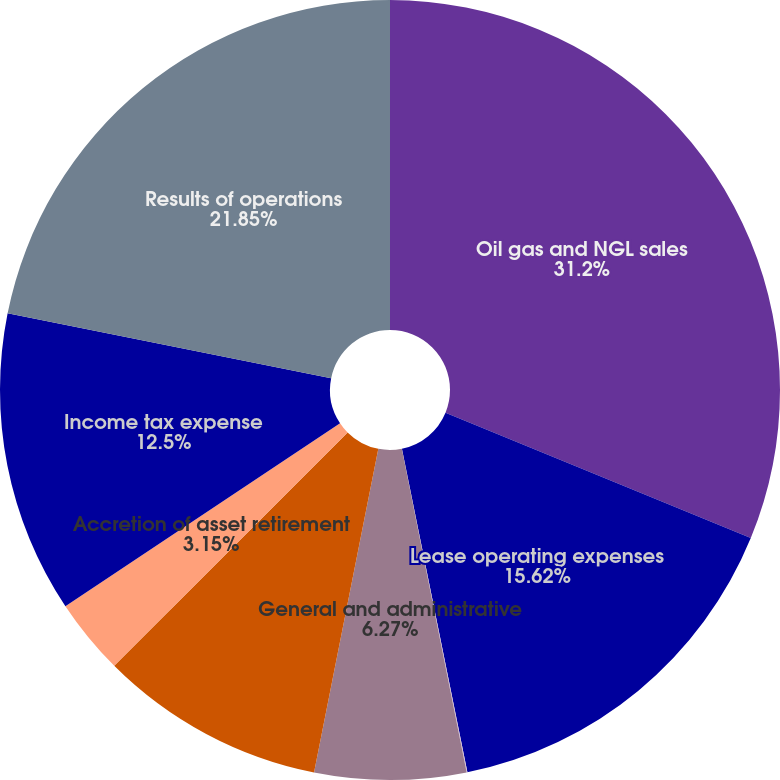Convert chart. <chart><loc_0><loc_0><loc_500><loc_500><pie_chart><fcel>Oil gas and NGL sales<fcel>Lease operating expenses<fcel>Depreciation depletion and<fcel>General and administrative<fcel>Taxes other than income taxes<fcel>Accretion of asset retirement<fcel>Income tax expense<fcel>Results of operations<nl><fcel>31.2%<fcel>15.62%<fcel>0.03%<fcel>6.27%<fcel>9.38%<fcel>3.15%<fcel>12.5%<fcel>21.85%<nl></chart> 